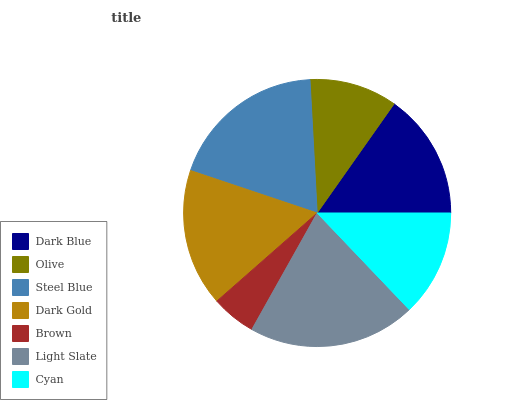Is Brown the minimum?
Answer yes or no. Yes. Is Light Slate the maximum?
Answer yes or no. Yes. Is Olive the minimum?
Answer yes or no. No. Is Olive the maximum?
Answer yes or no. No. Is Dark Blue greater than Olive?
Answer yes or no. Yes. Is Olive less than Dark Blue?
Answer yes or no. Yes. Is Olive greater than Dark Blue?
Answer yes or no. No. Is Dark Blue less than Olive?
Answer yes or no. No. Is Dark Blue the high median?
Answer yes or no. Yes. Is Dark Blue the low median?
Answer yes or no. Yes. Is Brown the high median?
Answer yes or no. No. Is Olive the low median?
Answer yes or no. No. 